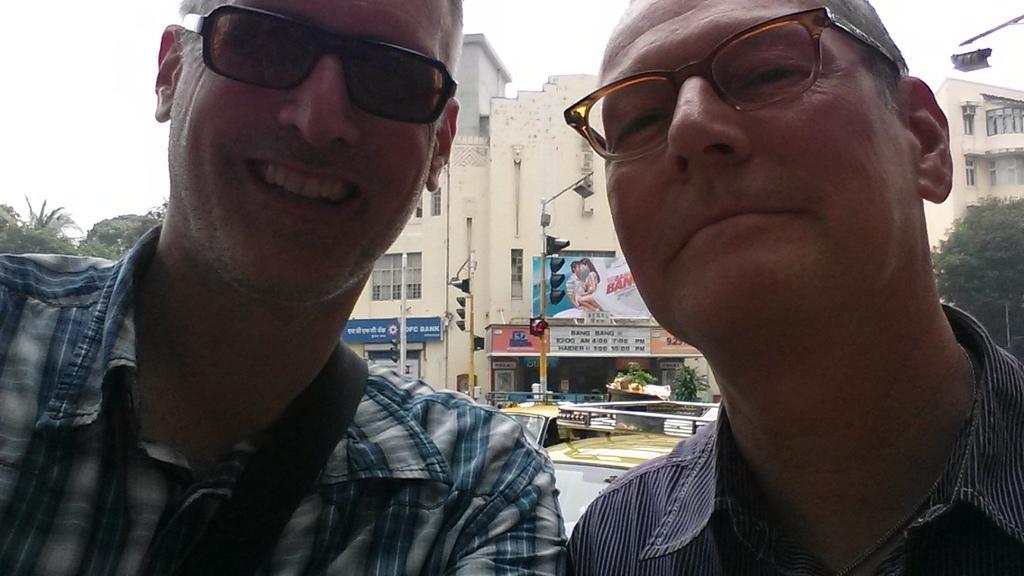How would you summarize this image in a sentence or two? Here we can see two men and they have spectacles. In the background we can see buildings, poles, traffic signals, boards, trees, vehicles, and sky. 